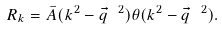<formula> <loc_0><loc_0><loc_500><loc_500>R _ { k } = \bar { A } ( k ^ { 2 } - \vec { q } \ ^ { 2 } ) \theta ( k ^ { 2 } - \vec { q } \ ^ { 2 } ) .</formula> 